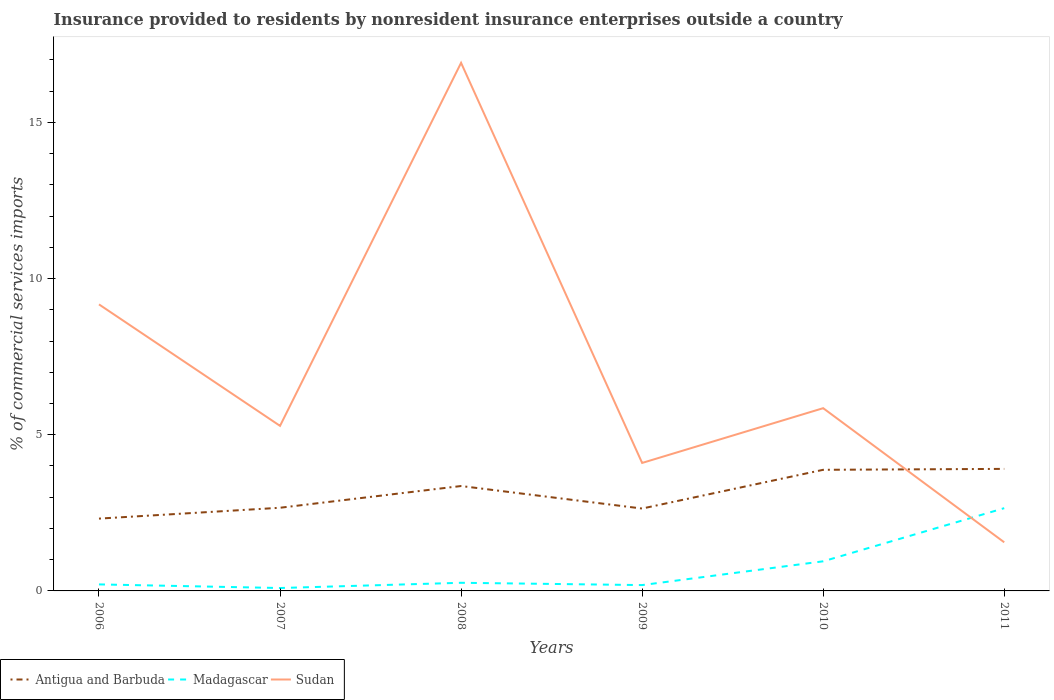Is the number of lines equal to the number of legend labels?
Your response must be concise. Yes. Across all years, what is the maximum Insurance provided to residents in Sudan?
Provide a short and direct response. 1.56. In which year was the Insurance provided to residents in Madagascar maximum?
Provide a short and direct response. 2007. What is the total Insurance provided to residents in Madagascar in the graph?
Your answer should be compact. -2.46. What is the difference between the highest and the second highest Insurance provided to residents in Madagascar?
Offer a very short reply. 2.56. Is the Insurance provided to residents in Antigua and Barbuda strictly greater than the Insurance provided to residents in Sudan over the years?
Your response must be concise. No. What is the difference between two consecutive major ticks on the Y-axis?
Your answer should be very brief. 5. Are the values on the major ticks of Y-axis written in scientific E-notation?
Ensure brevity in your answer.  No. Does the graph contain grids?
Your answer should be very brief. No. How many legend labels are there?
Provide a short and direct response. 3. What is the title of the graph?
Offer a terse response. Insurance provided to residents by nonresident insurance enterprises outside a country. Does "Bolivia" appear as one of the legend labels in the graph?
Offer a terse response. No. What is the label or title of the Y-axis?
Provide a succinct answer. % of commercial services imports. What is the % of commercial services imports in Antigua and Barbuda in 2006?
Ensure brevity in your answer.  2.32. What is the % of commercial services imports in Madagascar in 2006?
Provide a succinct answer. 0.21. What is the % of commercial services imports of Sudan in 2006?
Your answer should be very brief. 9.17. What is the % of commercial services imports of Antigua and Barbuda in 2007?
Provide a short and direct response. 2.66. What is the % of commercial services imports of Madagascar in 2007?
Offer a terse response. 0.09. What is the % of commercial services imports of Sudan in 2007?
Keep it short and to the point. 5.29. What is the % of commercial services imports in Antigua and Barbuda in 2008?
Your answer should be very brief. 3.36. What is the % of commercial services imports in Madagascar in 2008?
Provide a short and direct response. 0.26. What is the % of commercial services imports in Sudan in 2008?
Ensure brevity in your answer.  16.91. What is the % of commercial services imports in Antigua and Barbuda in 2009?
Give a very brief answer. 2.64. What is the % of commercial services imports in Madagascar in 2009?
Your response must be concise. 0.19. What is the % of commercial services imports in Sudan in 2009?
Provide a short and direct response. 4.1. What is the % of commercial services imports of Antigua and Barbuda in 2010?
Offer a very short reply. 3.88. What is the % of commercial services imports of Madagascar in 2010?
Your response must be concise. 0.95. What is the % of commercial services imports in Sudan in 2010?
Provide a succinct answer. 5.85. What is the % of commercial services imports in Antigua and Barbuda in 2011?
Give a very brief answer. 3.91. What is the % of commercial services imports in Madagascar in 2011?
Provide a short and direct response. 2.65. What is the % of commercial services imports of Sudan in 2011?
Your response must be concise. 1.56. Across all years, what is the maximum % of commercial services imports in Antigua and Barbuda?
Your answer should be compact. 3.91. Across all years, what is the maximum % of commercial services imports in Madagascar?
Your response must be concise. 2.65. Across all years, what is the maximum % of commercial services imports in Sudan?
Provide a short and direct response. 16.91. Across all years, what is the minimum % of commercial services imports in Antigua and Barbuda?
Your answer should be compact. 2.32. Across all years, what is the minimum % of commercial services imports of Madagascar?
Your answer should be very brief. 0.09. Across all years, what is the minimum % of commercial services imports of Sudan?
Your answer should be compact. 1.56. What is the total % of commercial services imports of Antigua and Barbuda in the graph?
Ensure brevity in your answer.  18.76. What is the total % of commercial services imports in Madagascar in the graph?
Your answer should be very brief. 4.35. What is the total % of commercial services imports of Sudan in the graph?
Offer a terse response. 42.88. What is the difference between the % of commercial services imports in Antigua and Barbuda in 2006 and that in 2007?
Provide a short and direct response. -0.35. What is the difference between the % of commercial services imports of Madagascar in 2006 and that in 2007?
Ensure brevity in your answer.  0.12. What is the difference between the % of commercial services imports of Sudan in 2006 and that in 2007?
Your response must be concise. 3.89. What is the difference between the % of commercial services imports of Antigua and Barbuda in 2006 and that in 2008?
Your answer should be very brief. -1.04. What is the difference between the % of commercial services imports of Madagascar in 2006 and that in 2008?
Offer a very short reply. -0.05. What is the difference between the % of commercial services imports in Sudan in 2006 and that in 2008?
Ensure brevity in your answer.  -7.73. What is the difference between the % of commercial services imports in Antigua and Barbuda in 2006 and that in 2009?
Provide a succinct answer. -0.32. What is the difference between the % of commercial services imports in Madagascar in 2006 and that in 2009?
Your answer should be compact. 0.02. What is the difference between the % of commercial services imports in Sudan in 2006 and that in 2009?
Give a very brief answer. 5.08. What is the difference between the % of commercial services imports of Antigua and Barbuda in 2006 and that in 2010?
Provide a succinct answer. -1.56. What is the difference between the % of commercial services imports of Madagascar in 2006 and that in 2010?
Offer a terse response. -0.74. What is the difference between the % of commercial services imports of Sudan in 2006 and that in 2010?
Offer a very short reply. 3.32. What is the difference between the % of commercial services imports of Antigua and Barbuda in 2006 and that in 2011?
Your response must be concise. -1.59. What is the difference between the % of commercial services imports of Madagascar in 2006 and that in 2011?
Your answer should be compact. -2.44. What is the difference between the % of commercial services imports in Sudan in 2006 and that in 2011?
Provide a short and direct response. 7.62. What is the difference between the % of commercial services imports in Antigua and Barbuda in 2007 and that in 2008?
Keep it short and to the point. -0.7. What is the difference between the % of commercial services imports in Madagascar in 2007 and that in 2008?
Provide a short and direct response. -0.17. What is the difference between the % of commercial services imports in Sudan in 2007 and that in 2008?
Ensure brevity in your answer.  -11.62. What is the difference between the % of commercial services imports in Antigua and Barbuda in 2007 and that in 2009?
Provide a short and direct response. 0.03. What is the difference between the % of commercial services imports in Madagascar in 2007 and that in 2009?
Make the answer very short. -0.09. What is the difference between the % of commercial services imports of Sudan in 2007 and that in 2009?
Offer a terse response. 1.19. What is the difference between the % of commercial services imports in Antigua and Barbuda in 2007 and that in 2010?
Give a very brief answer. -1.22. What is the difference between the % of commercial services imports in Madagascar in 2007 and that in 2010?
Provide a short and direct response. -0.86. What is the difference between the % of commercial services imports of Sudan in 2007 and that in 2010?
Provide a succinct answer. -0.57. What is the difference between the % of commercial services imports in Antigua and Barbuda in 2007 and that in 2011?
Keep it short and to the point. -1.24. What is the difference between the % of commercial services imports of Madagascar in 2007 and that in 2011?
Give a very brief answer. -2.56. What is the difference between the % of commercial services imports in Sudan in 2007 and that in 2011?
Offer a very short reply. 3.73. What is the difference between the % of commercial services imports of Antigua and Barbuda in 2008 and that in 2009?
Provide a succinct answer. 0.72. What is the difference between the % of commercial services imports in Madagascar in 2008 and that in 2009?
Ensure brevity in your answer.  0.07. What is the difference between the % of commercial services imports of Sudan in 2008 and that in 2009?
Give a very brief answer. 12.81. What is the difference between the % of commercial services imports of Antigua and Barbuda in 2008 and that in 2010?
Provide a short and direct response. -0.52. What is the difference between the % of commercial services imports in Madagascar in 2008 and that in 2010?
Provide a short and direct response. -0.69. What is the difference between the % of commercial services imports in Sudan in 2008 and that in 2010?
Provide a succinct answer. 11.06. What is the difference between the % of commercial services imports of Antigua and Barbuda in 2008 and that in 2011?
Offer a very short reply. -0.55. What is the difference between the % of commercial services imports in Madagascar in 2008 and that in 2011?
Offer a very short reply. -2.39. What is the difference between the % of commercial services imports in Sudan in 2008 and that in 2011?
Make the answer very short. 15.35. What is the difference between the % of commercial services imports in Antigua and Barbuda in 2009 and that in 2010?
Provide a succinct answer. -1.24. What is the difference between the % of commercial services imports in Madagascar in 2009 and that in 2010?
Provide a succinct answer. -0.76. What is the difference between the % of commercial services imports in Sudan in 2009 and that in 2010?
Keep it short and to the point. -1.75. What is the difference between the % of commercial services imports in Antigua and Barbuda in 2009 and that in 2011?
Ensure brevity in your answer.  -1.27. What is the difference between the % of commercial services imports of Madagascar in 2009 and that in 2011?
Your response must be concise. -2.46. What is the difference between the % of commercial services imports of Sudan in 2009 and that in 2011?
Your answer should be compact. 2.54. What is the difference between the % of commercial services imports in Antigua and Barbuda in 2010 and that in 2011?
Make the answer very short. -0.03. What is the difference between the % of commercial services imports in Madagascar in 2010 and that in 2011?
Ensure brevity in your answer.  -1.7. What is the difference between the % of commercial services imports in Sudan in 2010 and that in 2011?
Offer a very short reply. 4.29. What is the difference between the % of commercial services imports of Antigua and Barbuda in 2006 and the % of commercial services imports of Madagascar in 2007?
Your answer should be compact. 2.22. What is the difference between the % of commercial services imports in Antigua and Barbuda in 2006 and the % of commercial services imports in Sudan in 2007?
Offer a terse response. -2.97. What is the difference between the % of commercial services imports of Madagascar in 2006 and the % of commercial services imports of Sudan in 2007?
Keep it short and to the point. -5.08. What is the difference between the % of commercial services imports of Antigua and Barbuda in 2006 and the % of commercial services imports of Madagascar in 2008?
Ensure brevity in your answer.  2.06. What is the difference between the % of commercial services imports of Antigua and Barbuda in 2006 and the % of commercial services imports of Sudan in 2008?
Keep it short and to the point. -14.59. What is the difference between the % of commercial services imports of Madagascar in 2006 and the % of commercial services imports of Sudan in 2008?
Your response must be concise. -16.7. What is the difference between the % of commercial services imports of Antigua and Barbuda in 2006 and the % of commercial services imports of Madagascar in 2009?
Your response must be concise. 2.13. What is the difference between the % of commercial services imports in Antigua and Barbuda in 2006 and the % of commercial services imports in Sudan in 2009?
Keep it short and to the point. -1.78. What is the difference between the % of commercial services imports of Madagascar in 2006 and the % of commercial services imports of Sudan in 2009?
Keep it short and to the point. -3.89. What is the difference between the % of commercial services imports in Antigua and Barbuda in 2006 and the % of commercial services imports in Madagascar in 2010?
Your response must be concise. 1.37. What is the difference between the % of commercial services imports in Antigua and Barbuda in 2006 and the % of commercial services imports in Sudan in 2010?
Offer a terse response. -3.54. What is the difference between the % of commercial services imports of Madagascar in 2006 and the % of commercial services imports of Sudan in 2010?
Your answer should be compact. -5.64. What is the difference between the % of commercial services imports of Antigua and Barbuda in 2006 and the % of commercial services imports of Madagascar in 2011?
Your response must be concise. -0.33. What is the difference between the % of commercial services imports of Antigua and Barbuda in 2006 and the % of commercial services imports of Sudan in 2011?
Make the answer very short. 0.76. What is the difference between the % of commercial services imports in Madagascar in 2006 and the % of commercial services imports in Sudan in 2011?
Your answer should be compact. -1.35. What is the difference between the % of commercial services imports in Antigua and Barbuda in 2007 and the % of commercial services imports in Madagascar in 2008?
Provide a short and direct response. 2.4. What is the difference between the % of commercial services imports of Antigua and Barbuda in 2007 and the % of commercial services imports of Sudan in 2008?
Provide a succinct answer. -14.25. What is the difference between the % of commercial services imports in Madagascar in 2007 and the % of commercial services imports in Sudan in 2008?
Ensure brevity in your answer.  -16.82. What is the difference between the % of commercial services imports of Antigua and Barbuda in 2007 and the % of commercial services imports of Madagascar in 2009?
Ensure brevity in your answer.  2.48. What is the difference between the % of commercial services imports in Antigua and Barbuda in 2007 and the % of commercial services imports in Sudan in 2009?
Ensure brevity in your answer.  -1.44. What is the difference between the % of commercial services imports of Madagascar in 2007 and the % of commercial services imports of Sudan in 2009?
Make the answer very short. -4. What is the difference between the % of commercial services imports of Antigua and Barbuda in 2007 and the % of commercial services imports of Madagascar in 2010?
Provide a short and direct response. 1.71. What is the difference between the % of commercial services imports of Antigua and Barbuda in 2007 and the % of commercial services imports of Sudan in 2010?
Provide a succinct answer. -3.19. What is the difference between the % of commercial services imports of Madagascar in 2007 and the % of commercial services imports of Sudan in 2010?
Provide a short and direct response. -5.76. What is the difference between the % of commercial services imports in Antigua and Barbuda in 2007 and the % of commercial services imports in Madagascar in 2011?
Make the answer very short. 0.01. What is the difference between the % of commercial services imports of Antigua and Barbuda in 2007 and the % of commercial services imports of Sudan in 2011?
Your answer should be compact. 1.11. What is the difference between the % of commercial services imports of Madagascar in 2007 and the % of commercial services imports of Sudan in 2011?
Offer a very short reply. -1.46. What is the difference between the % of commercial services imports in Antigua and Barbuda in 2008 and the % of commercial services imports in Madagascar in 2009?
Your answer should be compact. 3.17. What is the difference between the % of commercial services imports of Antigua and Barbuda in 2008 and the % of commercial services imports of Sudan in 2009?
Keep it short and to the point. -0.74. What is the difference between the % of commercial services imports in Madagascar in 2008 and the % of commercial services imports in Sudan in 2009?
Keep it short and to the point. -3.84. What is the difference between the % of commercial services imports of Antigua and Barbuda in 2008 and the % of commercial services imports of Madagascar in 2010?
Offer a terse response. 2.41. What is the difference between the % of commercial services imports of Antigua and Barbuda in 2008 and the % of commercial services imports of Sudan in 2010?
Ensure brevity in your answer.  -2.49. What is the difference between the % of commercial services imports of Madagascar in 2008 and the % of commercial services imports of Sudan in 2010?
Provide a succinct answer. -5.59. What is the difference between the % of commercial services imports of Antigua and Barbuda in 2008 and the % of commercial services imports of Madagascar in 2011?
Your answer should be compact. 0.71. What is the difference between the % of commercial services imports of Antigua and Barbuda in 2008 and the % of commercial services imports of Sudan in 2011?
Make the answer very short. 1.8. What is the difference between the % of commercial services imports of Madagascar in 2008 and the % of commercial services imports of Sudan in 2011?
Offer a terse response. -1.3. What is the difference between the % of commercial services imports of Antigua and Barbuda in 2009 and the % of commercial services imports of Madagascar in 2010?
Offer a very short reply. 1.69. What is the difference between the % of commercial services imports of Antigua and Barbuda in 2009 and the % of commercial services imports of Sudan in 2010?
Ensure brevity in your answer.  -3.21. What is the difference between the % of commercial services imports of Madagascar in 2009 and the % of commercial services imports of Sudan in 2010?
Ensure brevity in your answer.  -5.66. What is the difference between the % of commercial services imports in Antigua and Barbuda in 2009 and the % of commercial services imports in Madagascar in 2011?
Offer a very short reply. -0.01. What is the difference between the % of commercial services imports of Antigua and Barbuda in 2009 and the % of commercial services imports of Sudan in 2011?
Keep it short and to the point. 1.08. What is the difference between the % of commercial services imports of Madagascar in 2009 and the % of commercial services imports of Sudan in 2011?
Provide a short and direct response. -1.37. What is the difference between the % of commercial services imports of Antigua and Barbuda in 2010 and the % of commercial services imports of Madagascar in 2011?
Provide a short and direct response. 1.23. What is the difference between the % of commercial services imports of Antigua and Barbuda in 2010 and the % of commercial services imports of Sudan in 2011?
Keep it short and to the point. 2.32. What is the difference between the % of commercial services imports of Madagascar in 2010 and the % of commercial services imports of Sudan in 2011?
Provide a short and direct response. -0.61. What is the average % of commercial services imports in Antigua and Barbuda per year?
Ensure brevity in your answer.  3.13. What is the average % of commercial services imports of Madagascar per year?
Make the answer very short. 0.72. What is the average % of commercial services imports in Sudan per year?
Ensure brevity in your answer.  7.15. In the year 2006, what is the difference between the % of commercial services imports in Antigua and Barbuda and % of commercial services imports in Madagascar?
Offer a terse response. 2.11. In the year 2006, what is the difference between the % of commercial services imports in Antigua and Barbuda and % of commercial services imports in Sudan?
Keep it short and to the point. -6.86. In the year 2006, what is the difference between the % of commercial services imports in Madagascar and % of commercial services imports in Sudan?
Give a very brief answer. -8.97. In the year 2007, what is the difference between the % of commercial services imports of Antigua and Barbuda and % of commercial services imports of Madagascar?
Your response must be concise. 2.57. In the year 2007, what is the difference between the % of commercial services imports of Antigua and Barbuda and % of commercial services imports of Sudan?
Offer a very short reply. -2.62. In the year 2007, what is the difference between the % of commercial services imports in Madagascar and % of commercial services imports in Sudan?
Keep it short and to the point. -5.19. In the year 2008, what is the difference between the % of commercial services imports in Antigua and Barbuda and % of commercial services imports in Madagascar?
Offer a terse response. 3.1. In the year 2008, what is the difference between the % of commercial services imports in Antigua and Barbuda and % of commercial services imports in Sudan?
Your answer should be compact. -13.55. In the year 2008, what is the difference between the % of commercial services imports in Madagascar and % of commercial services imports in Sudan?
Provide a succinct answer. -16.65. In the year 2009, what is the difference between the % of commercial services imports of Antigua and Barbuda and % of commercial services imports of Madagascar?
Offer a very short reply. 2.45. In the year 2009, what is the difference between the % of commercial services imports of Antigua and Barbuda and % of commercial services imports of Sudan?
Keep it short and to the point. -1.46. In the year 2009, what is the difference between the % of commercial services imports in Madagascar and % of commercial services imports in Sudan?
Keep it short and to the point. -3.91. In the year 2010, what is the difference between the % of commercial services imports of Antigua and Barbuda and % of commercial services imports of Madagascar?
Your response must be concise. 2.93. In the year 2010, what is the difference between the % of commercial services imports in Antigua and Barbuda and % of commercial services imports in Sudan?
Your answer should be very brief. -1.97. In the year 2010, what is the difference between the % of commercial services imports in Madagascar and % of commercial services imports in Sudan?
Your answer should be compact. -4.9. In the year 2011, what is the difference between the % of commercial services imports in Antigua and Barbuda and % of commercial services imports in Madagascar?
Offer a terse response. 1.26. In the year 2011, what is the difference between the % of commercial services imports in Antigua and Barbuda and % of commercial services imports in Sudan?
Provide a succinct answer. 2.35. In the year 2011, what is the difference between the % of commercial services imports in Madagascar and % of commercial services imports in Sudan?
Give a very brief answer. 1.09. What is the ratio of the % of commercial services imports of Antigua and Barbuda in 2006 to that in 2007?
Offer a very short reply. 0.87. What is the ratio of the % of commercial services imports in Madagascar in 2006 to that in 2007?
Offer a very short reply. 2.24. What is the ratio of the % of commercial services imports in Sudan in 2006 to that in 2007?
Give a very brief answer. 1.74. What is the ratio of the % of commercial services imports in Antigua and Barbuda in 2006 to that in 2008?
Provide a short and direct response. 0.69. What is the ratio of the % of commercial services imports of Madagascar in 2006 to that in 2008?
Offer a very short reply. 0.8. What is the ratio of the % of commercial services imports of Sudan in 2006 to that in 2008?
Your answer should be very brief. 0.54. What is the ratio of the % of commercial services imports of Antigua and Barbuda in 2006 to that in 2009?
Ensure brevity in your answer.  0.88. What is the ratio of the % of commercial services imports of Madagascar in 2006 to that in 2009?
Provide a succinct answer. 1.12. What is the ratio of the % of commercial services imports in Sudan in 2006 to that in 2009?
Your answer should be very brief. 2.24. What is the ratio of the % of commercial services imports in Antigua and Barbuda in 2006 to that in 2010?
Provide a succinct answer. 0.6. What is the ratio of the % of commercial services imports of Madagascar in 2006 to that in 2010?
Provide a short and direct response. 0.22. What is the ratio of the % of commercial services imports in Sudan in 2006 to that in 2010?
Ensure brevity in your answer.  1.57. What is the ratio of the % of commercial services imports of Antigua and Barbuda in 2006 to that in 2011?
Provide a succinct answer. 0.59. What is the ratio of the % of commercial services imports in Madagascar in 2006 to that in 2011?
Ensure brevity in your answer.  0.08. What is the ratio of the % of commercial services imports in Sudan in 2006 to that in 2011?
Ensure brevity in your answer.  5.89. What is the ratio of the % of commercial services imports in Antigua and Barbuda in 2007 to that in 2008?
Your answer should be very brief. 0.79. What is the ratio of the % of commercial services imports in Madagascar in 2007 to that in 2008?
Your answer should be very brief. 0.36. What is the ratio of the % of commercial services imports of Sudan in 2007 to that in 2008?
Your answer should be very brief. 0.31. What is the ratio of the % of commercial services imports in Antigua and Barbuda in 2007 to that in 2009?
Keep it short and to the point. 1.01. What is the ratio of the % of commercial services imports of Madagascar in 2007 to that in 2009?
Make the answer very short. 0.5. What is the ratio of the % of commercial services imports of Sudan in 2007 to that in 2009?
Make the answer very short. 1.29. What is the ratio of the % of commercial services imports in Antigua and Barbuda in 2007 to that in 2010?
Your response must be concise. 0.69. What is the ratio of the % of commercial services imports of Madagascar in 2007 to that in 2010?
Provide a short and direct response. 0.1. What is the ratio of the % of commercial services imports of Sudan in 2007 to that in 2010?
Your answer should be compact. 0.9. What is the ratio of the % of commercial services imports in Antigua and Barbuda in 2007 to that in 2011?
Keep it short and to the point. 0.68. What is the ratio of the % of commercial services imports of Madagascar in 2007 to that in 2011?
Make the answer very short. 0.04. What is the ratio of the % of commercial services imports of Sudan in 2007 to that in 2011?
Provide a succinct answer. 3.4. What is the ratio of the % of commercial services imports of Antigua and Barbuda in 2008 to that in 2009?
Ensure brevity in your answer.  1.27. What is the ratio of the % of commercial services imports in Madagascar in 2008 to that in 2009?
Offer a terse response. 1.39. What is the ratio of the % of commercial services imports in Sudan in 2008 to that in 2009?
Your answer should be very brief. 4.13. What is the ratio of the % of commercial services imports in Antigua and Barbuda in 2008 to that in 2010?
Your answer should be compact. 0.87. What is the ratio of the % of commercial services imports of Madagascar in 2008 to that in 2010?
Your answer should be compact. 0.27. What is the ratio of the % of commercial services imports of Sudan in 2008 to that in 2010?
Your answer should be compact. 2.89. What is the ratio of the % of commercial services imports in Antigua and Barbuda in 2008 to that in 2011?
Your answer should be compact. 0.86. What is the ratio of the % of commercial services imports in Madagascar in 2008 to that in 2011?
Offer a very short reply. 0.1. What is the ratio of the % of commercial services imports in Sudan in 2008 to that in 2011?
Your response must be concise. 10.86. What is the ratio of the % of commercial services imports of Antigua and Barbuda in 2009 to that in 2010?
Give a very brief answer. 0.68. What is the ratio of the % of commercial services imports in Madagascar in 2009 to that in 2010?
Ensure brevity in your answer.  0.2. What is the ratio of the % of commercial services imports of Sudan in 2009 to that in 2010?
Your response must be concise. 0.7. What is the ratio of the % of commercial services imports in Antigua and Barbuda in 2009 to that in 2011?
Your response must be concise. 0.68. What is the ratio of the % of commercial services imports in Madagascar in 2009 to that in 2011?
Make the answer very short. 0.07. What is the ratio of the % of commercial services imports in Sudan in 2009 to that in 2011?
Offer a terse response. 2.63. What is the ratio of the % of commercial services imports in Antigua and Barbuda in 2010 to that in 2011?
Give a very brief answer. 0.99. What is the ratio of the % of commercial services imports of Madagascar in 2010 to that in 2011?
Give a very brief answer. 0.36. What is the ratio of the % of commercial services imports in Sudan in 2010 to that in 2011?
Provide a succinct answer. 3.76. What is the difference between the highest and the second highest % of commercial services imports in Antigua and Barbuda?
Your response must be concise. 0.03. What is the difference between the highest and the second highest % of commercial services imports in Madagascar?
Your response must be concise. 1.7. What is the difference between the highest and the second highest % of commercial services imports of Sudan?
Make the answer very short. 7.73. What is the difference between the highest and the lowest % of commercial services imports of Antigua and Barbuda?
Make the answer very short. 1.59. What is the difference between the highest and the lowest % of commercial services imports of Madagascar?
Ensure brevity in your answer.  2.56. What is the difference between the highest and the lowest % of commercial services imports in Sudan?
Your answer should be compact. 15.35. 